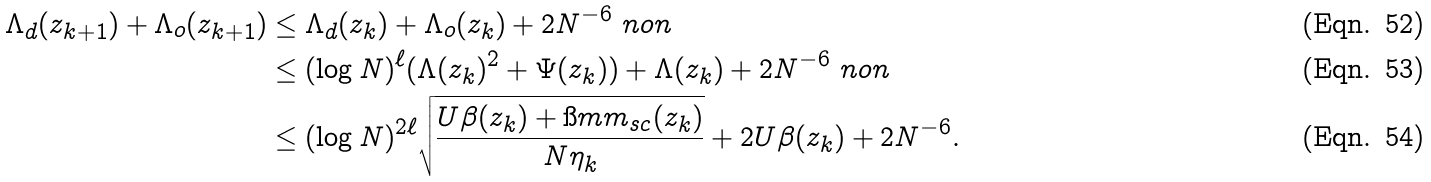<formula> <loc_0><loc_0><loc_500><loc_500>\Lambda _ { d } ( z _ { k + 1 } ) + \Lambda _ { o } ( z _ { k + 1 } ) & \leq \Lambda _ { d } ( z _ { k } ) + \Lambda _ { o } ( z _ { k } ) + 2 N ^ { - 6 } \ n o n \\ & \leq ( \log N ) ^ { \ell } ( \Lambda ( z _ { k } ) ^ { 2 } + \Psi ( z _ { k } ) ) + \Lambda ( z _ { k } ) + 2 N ^ { - 6 } \ n o n \\ & \leq ( \log N ) ^ { 2 \ell } \sqrt { \frac { U \beta ( z _ { k } ) + \i m m _ { s c } ( z _ { k } ) } { N \eta _ { k } } } + 2 U \beta ( z _ { k } ) + 2 N ^ { - 6 } .</formula> 